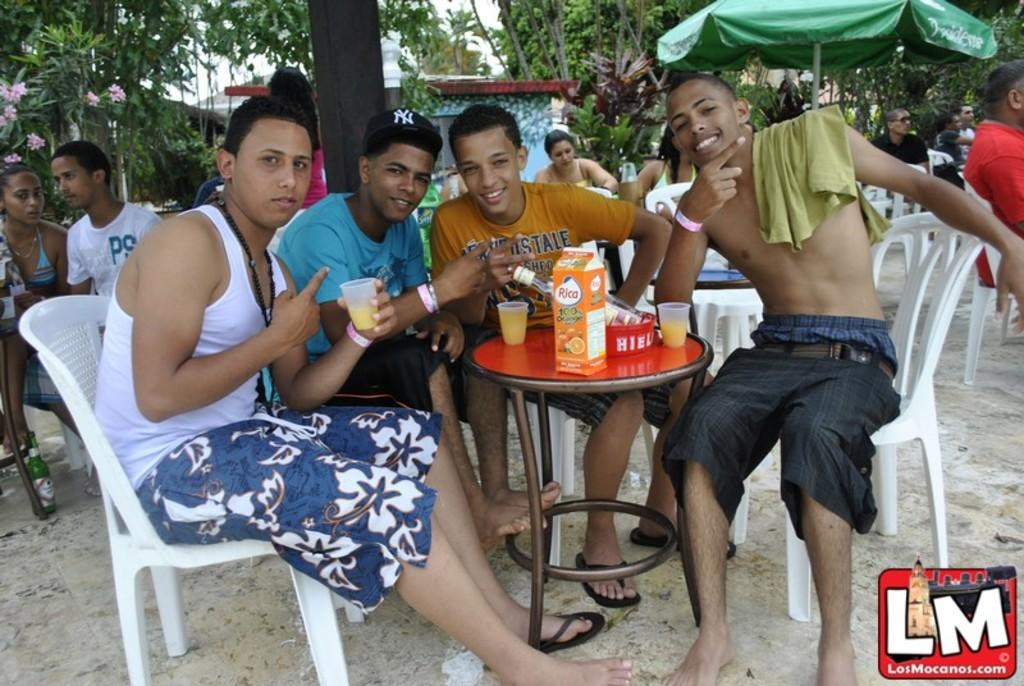How many people are the people in the image are positioned? There are four people in the image, and they are sitting on chairs. What are the people in the image doing? The people are having a drink. What can be seen in the background of the image? There is a tent, trees, and people in the background of the image. What type of plantation can be seen in the image? There is no plantation present in the image. How does the committee feel about the drink being served in the image? There is no committee mentioned in the image, and therefore their feelings cannot be determined. 